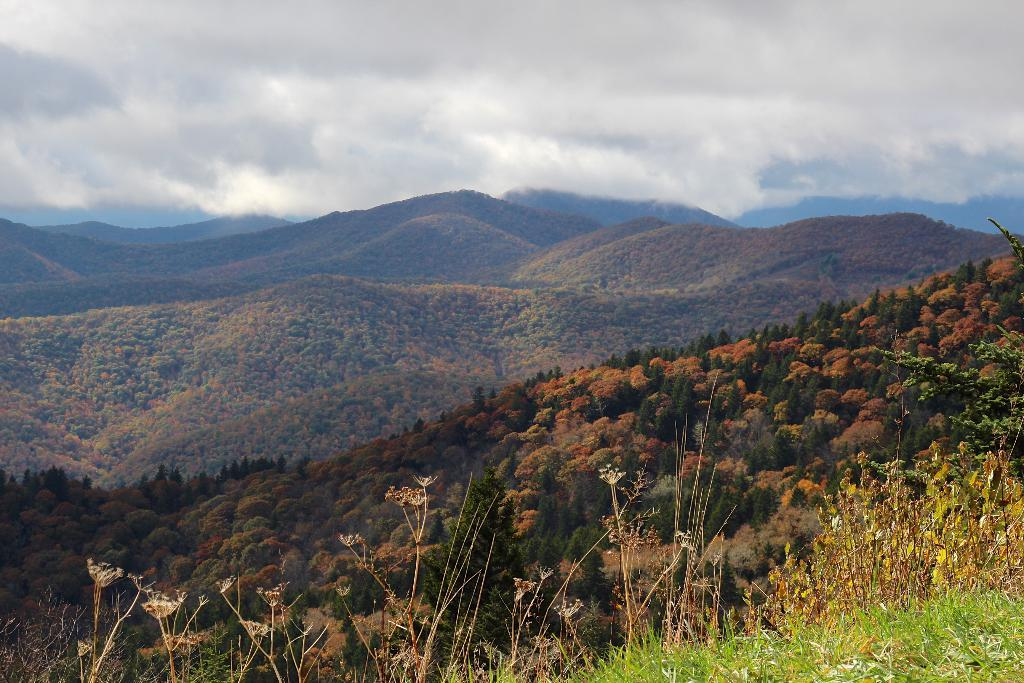What type of vegetation can be seen in the image? There is grass, plants, and trees in the image. What is visible in the background of the image? There is a mountain and sky visible in the background of the image. What can be seen in the sky? Clouds are present in the sky. Where is the oven located in the image? There is no oven present in the image. What type of party is being held in the image? There is no party depicted in the image. 